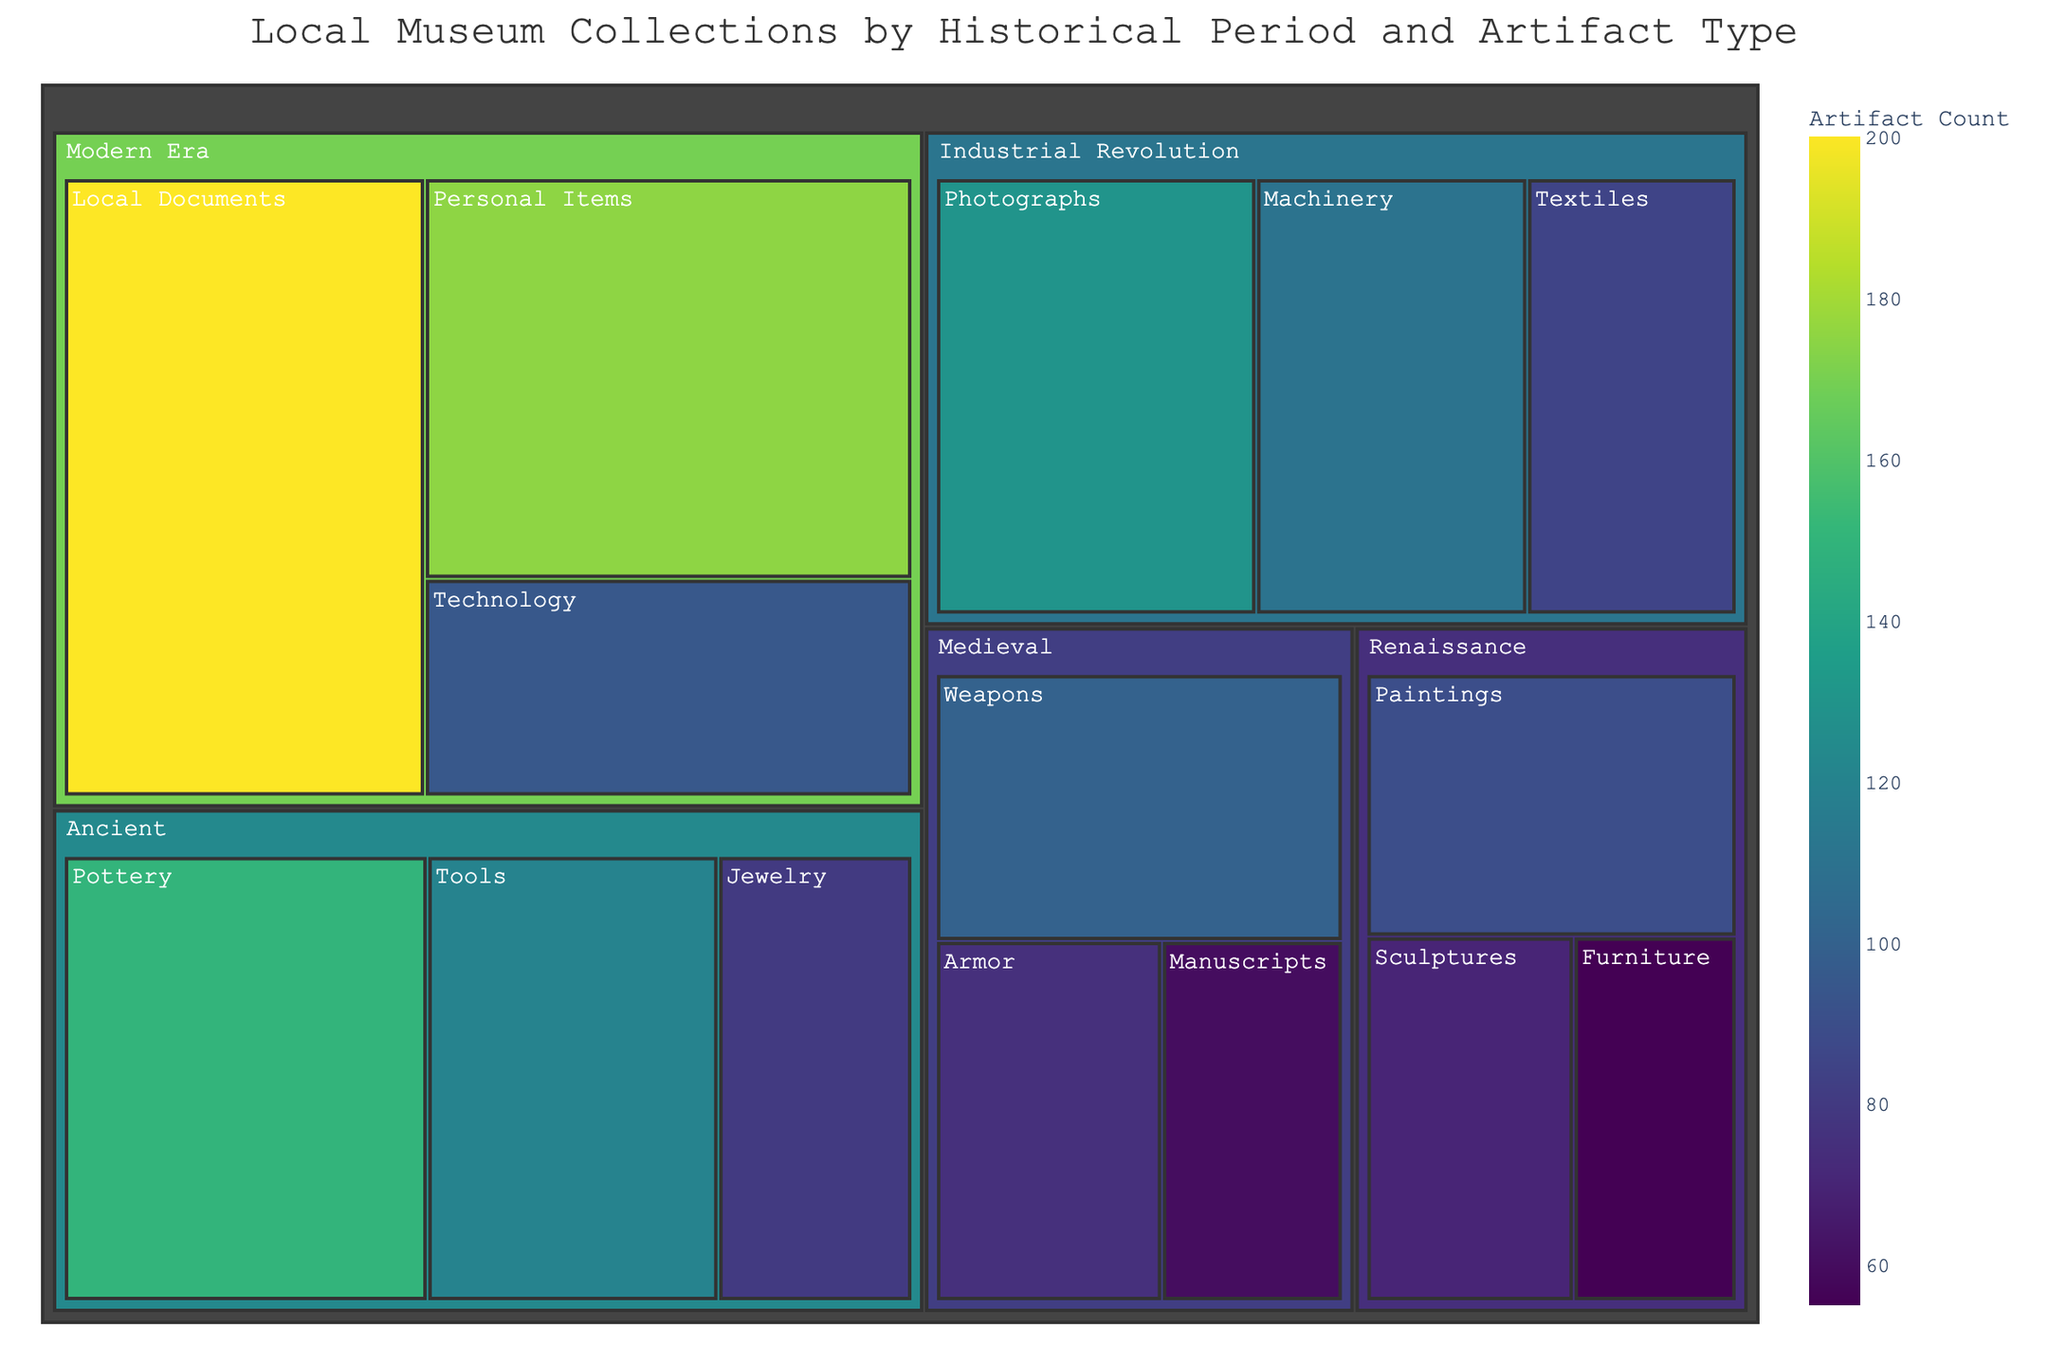What's the title of the Treemap? The title is found at the top of the figure, and it usually describes what the figure is about. In this case, we can read "Local Museum Collections by Historical Period and Artifact Type."
Answer: Local Museum Collections by Historical Period and Artifact Type Which historical period has the largest total count of artifacts? By examining the size of the blocks, the Modern Era has the largest aggregation of artifacts, especially due to the large block for Local Documents.
Answer: Modern Era How many Pottery artifacts are there in the Ancient period? Locate the Ancient period and then find the block labeled Pottery. Check the value displayed for it.
Answer: 150 Which artifact type has the smallest count in the Renaissance period? Look for the Renaissance period and compare the sizes of the blocks for each artifact type. The smallest block will be the one with the fewest artifacts.
Answer: Furniture What is the combined count of Weapons and Armor artifacts in the Medieval period? Locate the blocks for Weapons (100) and Armor (75) in the Medieval period, then sum their counts. 100 + 75 = 175
Answer: 175 Which period has more artifacts: the Industrial Revolution or the Renaissance? Sum the counts of all artifacts in each period and compare the totals. For the Industrial Revolution: 110 + 85 + 130 = 325; for Renaissance: 90 + 70 + 55 = 215. The Industrial Revolution has more.
Answer: Industrial Revolution What artifact type in the Modern Era has significantly fewer artifacts than Local Documents? By comparing the sizes of the blocks within the Modern Era, Personal Items and Technology are smaller. Between them, Technology (95) is significantly fewer than Local Documents (200).
Answer: Technology Which two artifact types have the highest counts across all periods? Compare the individual counts of each artifact type across all periods. Local Documents (200) and Personal Items (175), both in the Modern Era, are the highest.
Answer: Local Documents and Personal Items Are there more Tools artifacts in the Ancient period or Photographs in the Industrial Revolution? Compare the counts for Tools in Ancient (120) and Photographs in Industrial Revolution (130). Photographs has more artifacts.
Answer: Photographs 